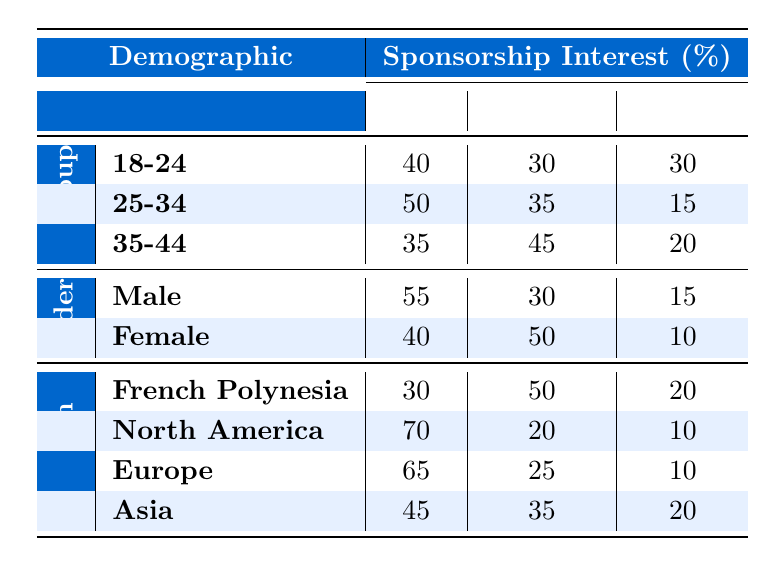What percentage of athletes aged 25-34 have high sponsorship interest? From the table, under the Age Group category for 25-34, the percentage of athletes with high sponsorship interest is directly listed as 50%.
Answer: 50% Which gender has a higher percentage of athletes interested in medium sponsorship? By comparing the Medium column under the Gender category, Male has 30% and Female has 50%. Therefore, Female has a higher percentage.
Answer: Female What is the total percentage of low sponsorship interest for athletes across all age groups? In the table, the low sponsorship interest percentages for the age groups are 30% (18-24) + 15% (25-34) + 20% (35-44) = 65%.
Answer: 65% Is it true that North America has the highest percentage of high sponsorship interest among regions? Looking at the High column under Region, North America has 70%, which is higher than all other regions listed (French Polynesia: 30%, Europe: 65%, Asia: 45%). Thus, the statement is true.
Answer: Yes What is the average percentage of high sponsorship interest for all demographics? To calculate the average, sum up the high percentages: 40% (18-24) + 50% (25-34) + 35% (35-44) + 55% (Male) + 40% (Female) + 30% (French Polynesia) + 70% (North America) + 65% (Europe) + 45% (Asia) =  410%. There are 9 categories, so the average is 410% / 9 = 45.56%.
Answer: 45.56% 